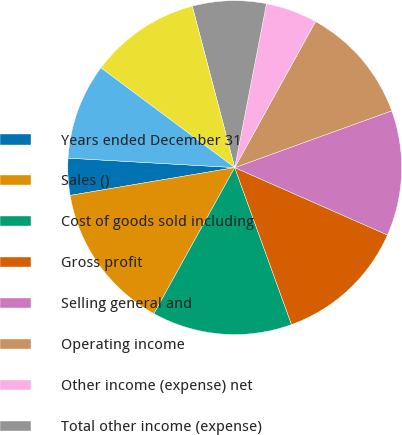Convert chart. <chart><loc_0><loc_0><loc_500><loc_500><pie_chart><fcel>Years ended December 31<fcel>Sales ()<fcel>Cost of goods sold including<fcel>Gross profit<fcel>Selling general and<fcel>Operating income<fcel>Other income (expense) net<fcel>Total other income (expense)<fcel>Income before income taxes<fcel>Provision for income taxes (a)<nl><fcel>3.57%<fcel>14.29%<fcel>13.57%<fcel>12.86%<fcel>12.14%<fcel>11.43%<fcel>5.0%<fcel>7.14%<fcel>10.71%<fcel>9.29%<nl></chart> 